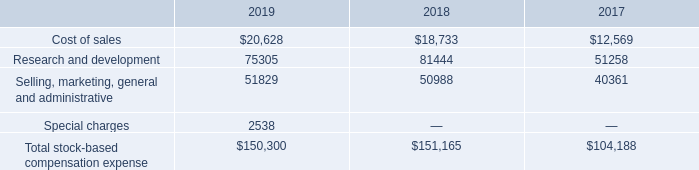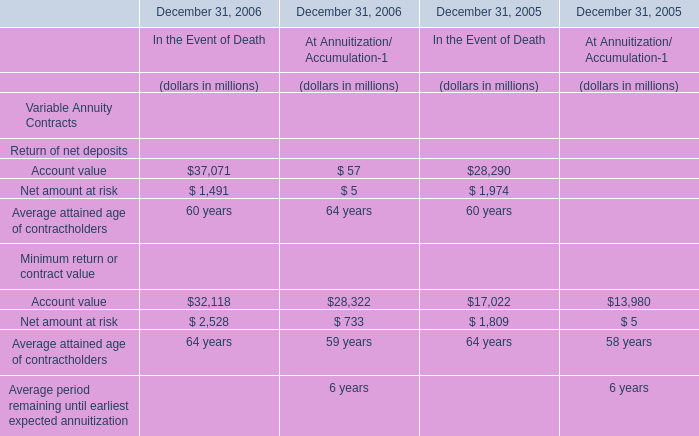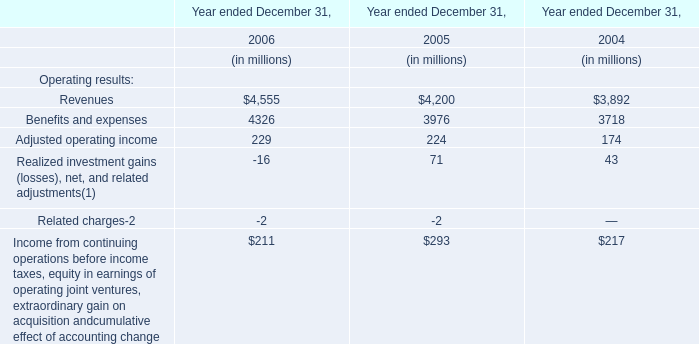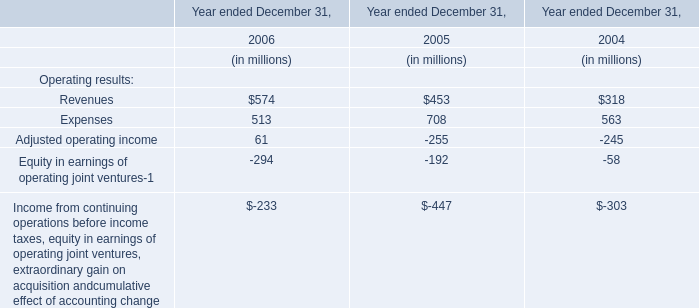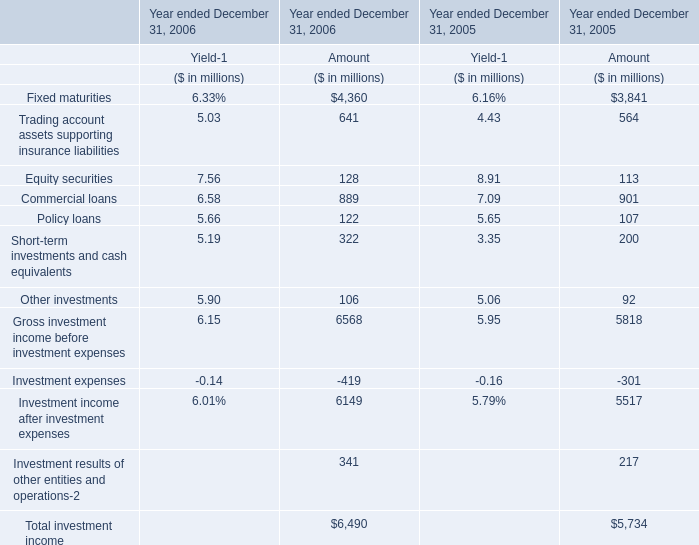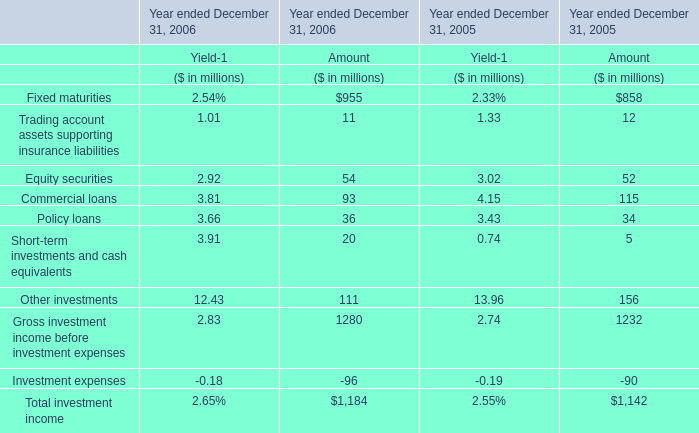If Fixed maturities develops with the same growth rate in 2006, what will it reach in 2007 for Amount? (in million) 
Computations: ((((955 - 858) / 955) * 955) + 955)
Answer: 1052.0. 